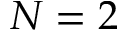<formula> <loc_0><loc_0><loc_500><loc_500>N = 2</formula> 